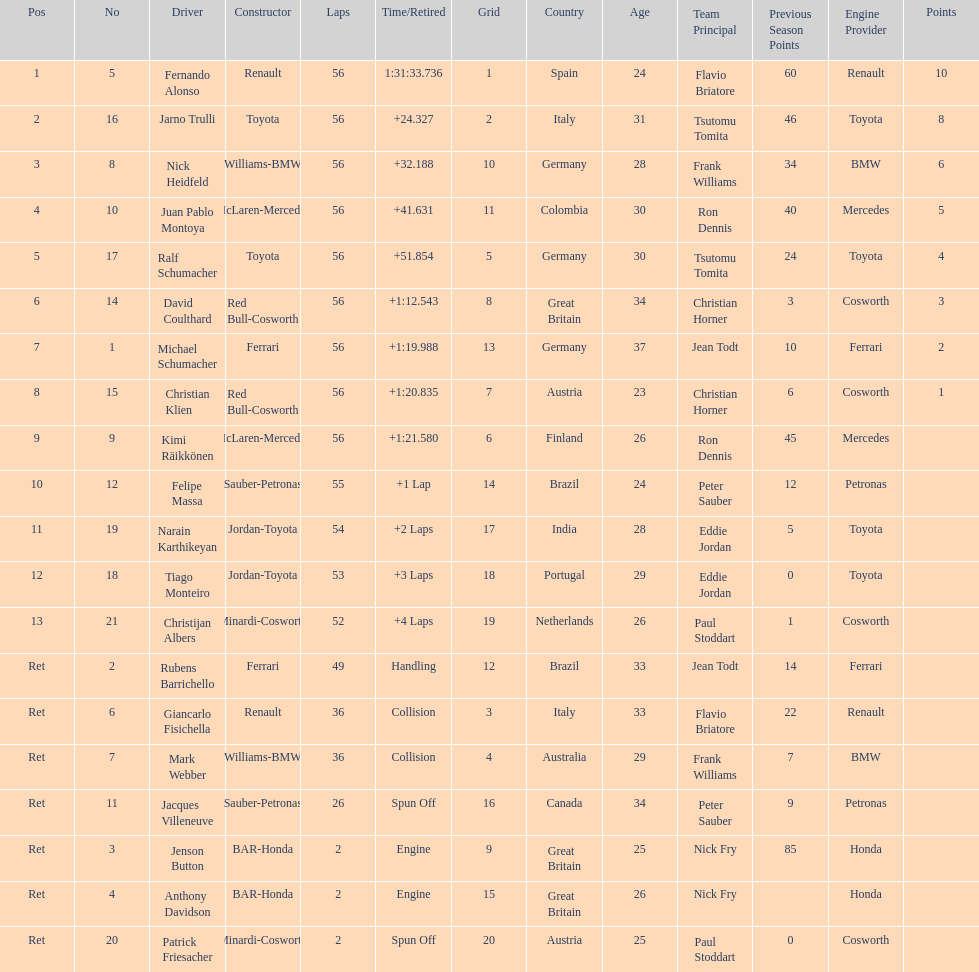Jarno trulli was not french but what nationality? Italian. 